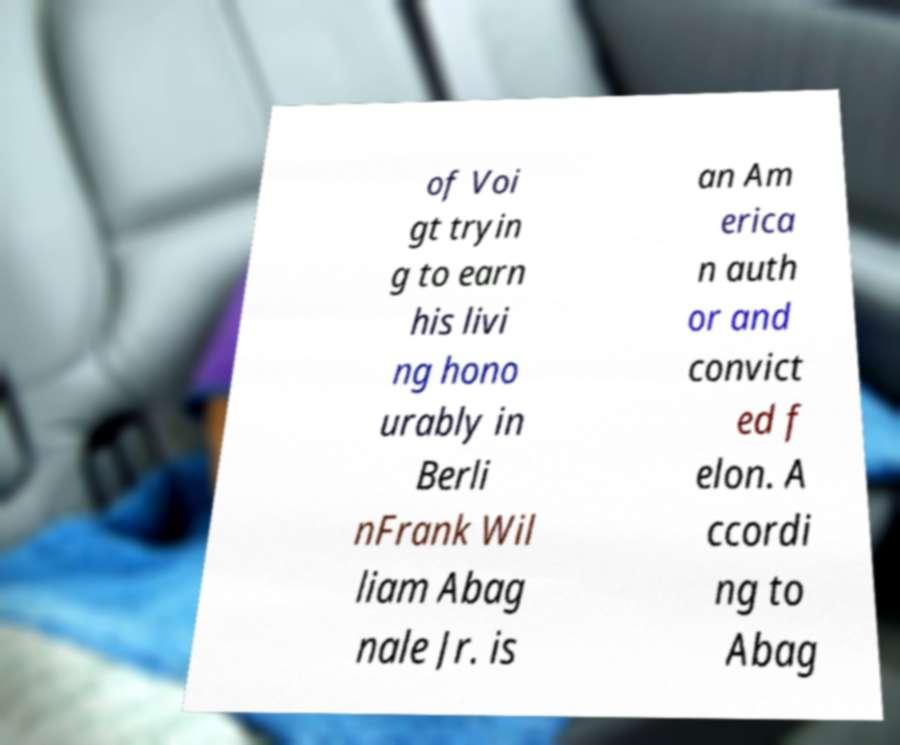Please read and relay the text visible in this image. What does it say? of Voi gt tryin g to earn his livi ng hono urably in Berli nFrank Wil liam Abag nale Jr. is an Am erica n auth or and convict ed f elon. A ccordi ng to Abag 